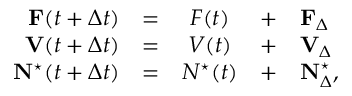Convert formula to latex. <formula><loc_0><loc_0><loc_500><loc_500>\begin{array} { r c c c l } { F ( t + \Delta t ) } & { = } & { F ( t ) } & { + } & { F _ { \Delta } } \\ { V ( t + \Delta t ) } & { = } & { V ( t ) } & { + } & { V _ { \Delta } } \\ { N ^ { ^ { * } } ( t + \Delta t ) } & { = } & { N ^ { ^ { * } } ( t ) } & { + } & { N _ { \Delta } ^ { ^ { * } } , } \end{array}</formula> 